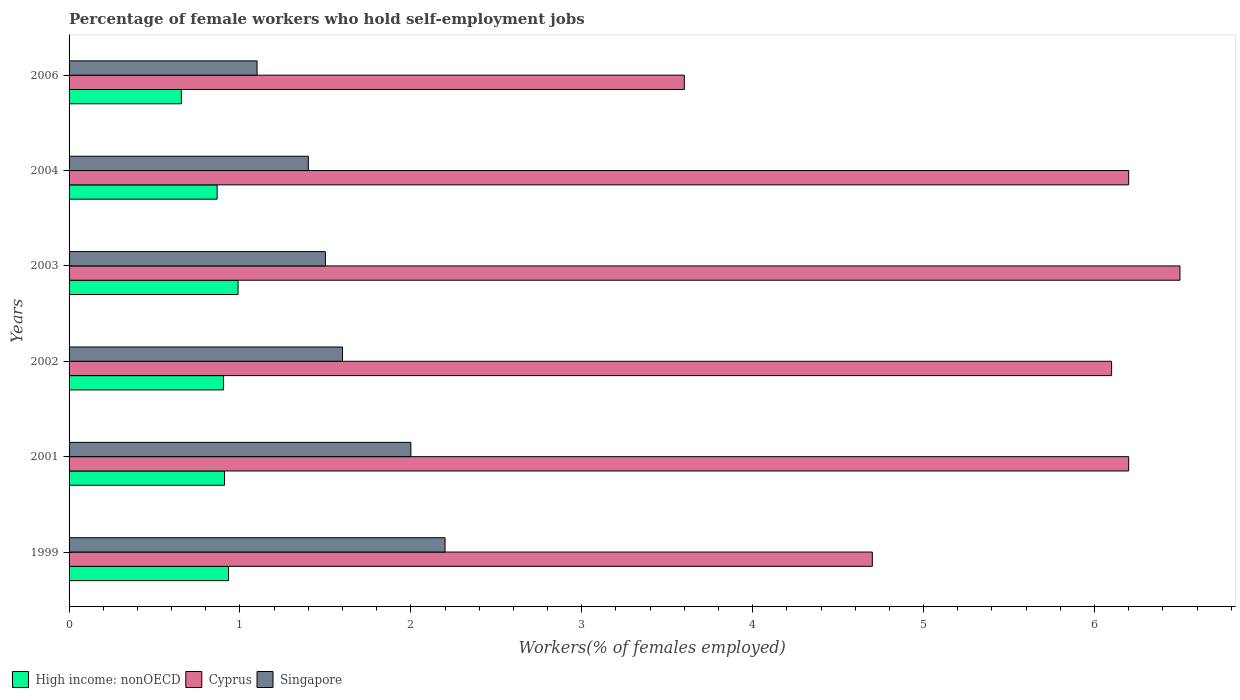How many different coloured bars are there?
Offer a terse response. 3. How many groups of bars are there?
Your answer should be very brief. 6. Are the number of bars on each tick of the Y-axis equal?
Ensure brevity in your answer.  Yes. How many bars are there on the 3rd tick from the bottom?
Your response must be concise. 3. What is the label of the 1st group of bars from the top?
Give a very brief answer. 2006. What is the percentage of self-employed female workers in Singapore in 1999?
Keep it short and to the point. 2.2. Across all years, what is the minimum percentage of self-employed female workers in Singapore?
Keep it short and to the point. 1.1. What is the total percentage of self-employed female workers in High income: nonOECD in the graph?
Your response must be concise. 5.26. What is the difference between the percentage of self-employed female workers in High income: nonOECD in 2001 and that in 2003?
Provide a short and direct response. -0.08. What is the difference between the percentage of self-employed female workers in Cyprus in 1999 and the percentage of self-employed female workers in High income: nonOECD in 2002?
Your answer should be compact. 3.8. What is the average percentage of self-employed female workers in High income: nonOECD per year?
Provide a succinct answer. 0.88. In the year 2001, what is the difference between the percentage of self-employed female workers in Singapore and percentage of self-employed female workers in Cyprus?
Your response must be concise. -4.2. What is the ratio of the percentage of self-employed female workers in High income: nonOECD in 2004 to that in 2006?
Your response must be concise. 1.32. Is the difference between the percentage of self-employed female workers in Singapore in 2001 and 2002 greater than the difference between the percentage of self-employed female workers in Cyprus in 2001 and 2002?
Provide a short and direct response. Yes. What is the difference between the highest and the second highest percentage of self-employed female workers in Cyprus?
Your answer should be very brief. 0.3. What is the difference between the highest and the lowest percentage of self-employed female workers in Singapore?
Your answer should be very brief. 1.1. In how many years, is the percentage of self-employed female workers in Singapore greater than the average percentage of self-employed female workers in Singapore taken over all years?
Provide a succinct answer. 2. Is the sum of the percentage of self-employed female workers in Singapore in 1999 and 2001 greater than the maximum percentage of self-employed female workers in High income: nonOECD across all years?
Your answer should be compact. Yes. What does the 1st bar from the top in 2002 represents?
Ensure brevity in your answer.  Singapore. What does the 2nd bar from the bottom in 2006 represents?
Your answer should be very brief. Cyprus. How many bars are there?
Give a very brief answer. 18. Are all the bars in the graph horizontal?
Provide a succinct answer. Yes. Are the values on the major ticks of X-axis written in scientific E-notation?
Provide a succinct answer. No. Does the graph contain any zero values?
Make the answer very short. No. Where does the legend appear in the graph?
Keep it short and to the point. Bottom left. How are the legend labels stacked?
Provide a succinct answer. Horizontal. What is the title of the graph?
Provide a succinct answer. Percentage of female workers who hold self-employment jobs. Does "Uzbekistan" appear as one of the legend labels in the graph?
Provide a succinct answer. No. What is the label or title of the X-axis?
Your answer should be very brief. Workers(% of females employed). What is the Workers(% of females employed) of High income: nonOECD in 1999?
Your answer should be compact. 0.93. What is the Workers(% of females employed) of Cyprus in 1999?
Your answer should be compact. 4.7. What is the Workers(% of females employed) of Singapore in 1999?
Provide a short and direct response. 2.2. What is the Workers(% of females employed) of High income: nonOECD in 2001?
Make the answer very short. 0.91. What is the Workers(% of females employed) in Cyprus in 2001?
Offer a very short reply. 6.2. What is the Workers(% of females employed) in High income: nonOECD in 2002?
Your answer should be very brief. 0.9. What is the Workers(% of females employed) in Cyprus in 2002?
Offer a very short reply. 6.1. What is the Workers(% of females employed) in Singapore in 2002?
Provide a short and direct response. 1.6. What is the Workers(% of females employed) in High income: nonOECD in 2003?
Your answer should be very brief. 0.99. What is the Workers(% of females employed) of Cyprus in 2003?
Offer a terse response. 6.5. What is the Workers(% of females employed) of High income: nonOECD in 2004?
Your answer should be very brief. 0.87. What is the Workers(% of females employed) in Cyprus in 2004?
Make the answer very short. 6.2. What is the Workers(% of females employed) of Singapore in 2004?
Offer a very short reply. 1.4. What is the Workers(% of females employed) of High income: nonOECD in 2006?
Offer a terse response. 0.66. What is the Workers(% of females employed) in Cyprus in 2006?
Ensure brevity in your answer.  3.6. What is the Workers(% of females employed) of Singapore in 2006?
Provide a short and direct response. 1.1. Across all years, what is the maximum Workers(% of females employed) in High income: nonOECD?
Offer a terse response. 0.99. Across all years, what is the maximum Workers(% of females employed) in Cyprus?
Provide a short and direct response. 6.5. Across all years, what is the maximum Workers(% of females employed) of Singapore?
Keep it short and to the point. 2.2. Across all years, what is the minimum Workers(% of females employed) in High income: nonOECD?
Your answer should be very brief. 0.66. Across all years, what is the minimum Workers(% of females employed) in Cyprus?
Your answer should be compact. 3.6. Across all years, what is the minimum Workers(% of females employed) of Singapore?
Offer a terse response. 1.1. What is the total Workers(% of females employed) of High income: nonOECD in the graph?
Your answer should be compact. 5.26. What is the total Workers(% of females employed) in Cyprus in the graph?
Ensure brevity in your answer.  33.3. What is the difference between the Workers(% of females employed) in High income: nonOECD in 1999 and that in 2001?
Give a very brief answer. 0.02. What is the difference between the Workers(% of females employed) of Cyprus in 1999 and that in 2001?
Your response must be concise. -1.5. What is the difference between the Workers(% of females employed) of High income: nonOECD in 1999 and that in 2002?
Provide a short and direct response. 0.03. What is the difference between the Workers(% of females employed) in Cyprus in 1999 and that in 2002?
Keep it short and to the point. -1.4. What is the difference between the Workers(% of females employed) of High income: nonOECD in 1999 and that in 2003?
Offer a very short reply. -0.06. What is the difference between the Workers(% of females employed) in Singapore in 1999 and that in 2003?
Make the answer very short. 0.7. What is the difference between the Workers(% of females employed) of High income: nonOECD in 1999 and that in 2004?
Provide a short and direct response. 0.07. What is the difference between the Workers(% of females employed) in High income: nonOECD in 1999 and that in 2006?
Your answer should be very brief. 0.28. What is the difference between the Workers(% of females employed) in Cyprus in 1999 and that in 2006?
Your answer should be very brief. 1.1. What is the difference between the Workers(% of females employed) in High income: nonOECD in 2001 and that in 2002?
Give a very brief answer. 0.01. What is the difference between the Workers(% of females employed) of Cyprus in 2001 and that in 2002?
Offer a very short reply. 0.1. What is the difference between the Workers(% of females employed) of Singapore in 2001 and that in 2002?
Provide a short and direct response. 0.4. What is the difference between the Workers(% of females employed) in High income: nonOECD in 2001 and that in 2003?
Your response must be concise. -0.08. What is the difference between the Workers(% of females employed) of Singapore in 2001 and that in 2003?
Provide a short and direct response. 0.5. What is the difference between the Workers(% of females employed) of High income: nonOECD in 2001 and that in 2004?
Provide a short and direct response. 0.04. What is the difference between the Workers(% of females employed) in Cyprus in 2001 and that in 2004?
Offer a terse response. 0. What is the difference between the Workers(% of females employed) in High income: nonOECD in 2001 and that in 2006?
Your answer should be very brief. 0.25. What is the difference between the Workers(% of females employed) of Cyprus in 2001 and that in 2006?
Provide a short and direct response. 2.6. What is the difference between the Workers(% of females employed) of Singapore in 2001 and that in 2006?
Keep it short and to the point. 0.9. What is the difference between the Workers(% of females employed) in High income: nonOECD in 2002 and that in 2003?
Your answer should be compact. -0.08. What is the difference between the Workers(% of females employed) of Singapore in 2002 and that in 2003?
Give a very brief answer. 0.1. What is the difference between the Workers(% of females employed) of High income: nonOECD in 2002 and that in 2004?
Your answer should be compact. 0.04. What is the difference between the Workers(% of females employed) of High income: nonOECD in 2002 and that in 2006?
Your answer should be very brief. 0.25. What is the difference between the Workers(% of females employed) in Cyprus in 2002 and that in 2006?
Provide a succinct answer. 2.5. What is the difference between the Workers(% of females employed) in Singapore in 2002 and that in 2006?
Ensure brevity in your answer.  0.5. What is the difference between the Workers(% of females employed) of High income: nonOECD in 2003 and that in 2004?
Ensure brevity in your answer.  0.12. What is the difference between the Workers(% of females employed) of High income: nonOECD in 2003 and that in 2006?
Make the answer very short. 0.33. What is the difference between the Workers(% of females employed) of Cyprus in 2003 and that in 2006?
Your answer should be very brief. 2.9. What is the difference between the Workers(% of females employed) of Singapore in 2003 and that in 2006?
Offer a very short reply. 0.4. What is the difference between the Workers(% of females employed) in High income: nonOECD in 2004 and that in 2006?
Your response must be concise. 0.21. What is the difference between the Workers(% of females employed) in Singapore in 2004 and that in 2006?
Ensure brevity in your answer.  0.3. What is the difference between the Workers(% of females employed) in High income: nonOECD in 1999 and the Workers(% of females employed) in Cyprus in 2001?
Provide a succinct answer. -5.27. What is the difference between the Workers(% of females employed) of High income: nonOECD in 1999 and the Workers(% of females employed) of Singapore in 2001?
Offer a very short reply. -1.07. What is the difference between the Workers(% of females employed) of Cyprus in 1999 and the Workers(% of females employed) of Singapore in 2001?
Keep it short and to the point. 2.7. What is the difference between the Workers(% of females employed) of High income: nonOECD in 1999 and the Workers(% of females employed) of Cyprus in 2002?
Keep it short and to the point. -5.17. What is the difference between the Workers(% of females employed) of High income: nonOECD in 1999 and the Workers(% of females employed) of Singapore in 2002?
Your answer should be very brief. -0.67. What is the difference between the Workers(% of females employed) of High income: nonOECD in 1999 and the Workers(% of females employed) of Cyprus in 2003?
Your response must be concise. -5.57. What is the difference between the Workers(% of females employed) in High income: nonOECD in 1999 and the Workers(% of females employed) in Singapore in 2003?
Your answer should be very brief. -0.57. What is the difference between the Workers(% of females employed) in Cyprus in 1999 and the Workers(% of females employed) in Singapore in 2003?
Your answer should be very brief. 3.2. What is the difference between the Workers(% of females employed) in High income: nonOECD in 1999 and the Workers(% of females employed) in Cyprus in 2004?
Ensure brevity in your answer.  -5.27. What is the difference between the Workers(% of females employed) in High income: nonOECD in 1999 and the Workers(% of females employed) in Singapore in 2004?
Make the answer very short. -0.47. What is the difference between the Workers(% of females employed) in High income: nonOECD in 1999 and the Workers(% of females employed) in Cyprus in 2006?
Offer a terse response. -2.67. What is the difference between the Workers(% of females employed) in High income: nonOECD in 1999 and the Workers(% of females employed) in Singapore in 2006?
Provide a short and direct response. -0.17. What is the difference between the Workers(% of females employed) of High income: nonOECD in 2001 and the Workers(% of females employed) of Cyprus in 2002?
Provide a succinct answer. -5.19. What is the difference between the Workers(% of females employed) of High income: nonOECD in 2001 and the Workers(% of females employed) of Singapore in 2002?
Provide a short and direct response. -0.69. What is the difference between the Workers(% of females employed) of Cyprus in 2001 and the Workers(% of females employed) of Singapore in 2002?
Keep it short and to the point. 4.6. What is the difference between the Workers(% of females employed) of High income: nonOECD in 2001 and the Workers(% of females employed) of Cyprus in 2003?
Your answer should be compact. -5.59. What is the difference between the Workers(% of females employed) in High income: nonOECD in 2001 and the Workers(% of females employed) in Singapore in 2003?
Provide a short and direct response. -0.59. What is the difference between the Workers(% of females employed) in High income: nonOECD in 2001 and the Workers(% of females employed) in Cyprus in 2004?
Make the answer very short. -5.29. What is the difference between the Workers(% of females employed) in High income: nonOECD in 2001 and the Workers(% of females employed) in Singapore in 2004?
Offer a terse response. -0.49. What is the difference between the Workers(% of females employed) in High income: nonOECD in 2001 and the Workers(% of females employed) in Cyprus in 2006?
Provide a succinct answer. -2.69. What is the difference between the Workers(% of females employed) of High income: nonOECD in 2001 and the Workers(% of females employed) of Singapore in 2006?
Ensure brevity in your answer.  -0.19. What is the difference between the Workers(% of females employed) in High income: nonOECD in 2002 and the Workers(% of females employed) in Cyprus in 2003?
Ensure brevity in your answer.  -5.6. What is the difference between the Workers(% of females employed) in High income: nonOECD in 2002 and the Workers(% of females employed) in Singapore in 2003?
Offer a very short reply. -0.6. What is the difference between the Workers(% of females employed) in High income: nonOECD in 2002 and the Workers(% of females employed) in Cyprus in 2004?
Your answer should be compact. -5.3. What is the difference between the Workers(% of females employed) of High income: nonOECD in 2002 and the Workers(% of females employed) of Singapore in 2004?
Keep it short and to the point. -0.5. What is the difference between the Workers(% of females employed) of Cyprus in 2002 and the Workers(% of females employed) of Singapore in 2004?
Provide a short and direct response. 4.7. What is the difference between the Workers(% of females employed) in High income: nonOECD in 2002 and the Workers(% of females employed) in Cyprus in 2006?
Offer a very short reply. -2.7. What is the difference between the Workers(% of females employed) in High income: nonOECD in 2002 and the Workers(% of females employed) in Singapore in 2006?
Your answer should be compact. -0.2. What is the difference between the Workers(% of females employed) of Cyprus in 2002 and the Workers(% of females employed) of Singapore in 2006?
Give a very brief answer. 5. What is the difference between the Workers(% of females employed) in High income: nonOECD in 2003 and the Workers(% of females employed) in Cyprus in 2004?
Ensure brevity in your answer.  -5.21. What is the difference between the Workers(% of females employed) in High income: nonOECD in 2003 and the Workers(% of females employed) in Singapore in 2004?
Your answer should be very brief. -0.41. What is the difference between the Workers(% of females employed) in High income: nonOECD in 2003 and the Workers(% of females employed) in Cyprus in 2006?
Make the answer very short. -2.61. What is the difference between the Workers(% of females employed) of High income: nonOECD in 2003 and the Workers(% of females employed) of Singapore in 2006?
Make the answer very short. -0.11. What is the difference between the Workers(% of females employed) of High income: nonOECD in 2004 and the Workers(% of females employed) of Cyprus in 2006?
Keep it short and to the point. -2.73. What is the difference between the Workers(% of females employed) of High income: nonOECD in 2004 and the Workers(% of females employed) of Singapore in 2006?
Keep it short and to the point. -0.23. What is the difference between the Workers(% of females employed) of Cyprus in 2004 and the Workers(% of females employed) of Singapore in 2006?
Your response must be concise. 5.1. What is the average Workers(% of females employed) of High income: nonOECD per year?
Give a very brief answer. 0.88. What is the average Workers(% of females employed) of Cyprus per year?
Ensure brevity in your answer.  5.55. What is the average Workers(% of females employed) in Singapore per year?
Offer a very short reply. 1.63. In the year 1999, what is the difference between the Workers(% of females employed) of High income: nonOECD and Workers(% of females employed) of Cyprus?
Give a very brief answer. -3.77. In the year 1999, what is the difference between the Workers(% of females employed) in High income: nonOECD and Workers(% of females employed) in Singapore?
Your answer should be compact. -1.27. In the year 2001, what is the difference between the Workers(% of females employed) of High income: nonOECD and Workers(% of females employed) of Cyprus?
Make the answer very short. -5.29. In the year 2001, what is the difference between the Workers(% of females employed) of High income: nonOECD and Workers(% of females employed) of Singapore?
Keep it short and to the point. -1.09. In the year 2001, what is the difference between the Workers(% of females employed) in Cyprus and Workers(% of females employed) in Singapore?
Offer a very short reply. 4.2. In the year 2002, what is the difference between the Workers(% of females employed) of High income: nonOECD and Workers(% of females employed) of Cyprus?
Give a very brief answer. -5.2. In the year 2002, what is the difference between the Workers(% of females employed) in High income: nonOECD and Workers(% of females employed) in Singapore?
Your answer should be compact. -0.7. In the year 2002, what is the difference between the Workers(% of females employed) in Cyprus and Workers(% of females employed) in Singapore?
Offer a terse response. 4.5. In the year 2003, what is the difference between the Workers(% of females employed) of High income: nonOECD and Workers(% of females employed) of Cyprus?
Provide a succinct answer. -5.51. In the year 2003, what is the difference between the Workers(% of females employed) of High income: nonOECD and Workers(% of females employed) of Singapore?
Provide a succinct answer. -0.51. In the year 2004, what is the difference between the Workers(% of females employed) in High income: nonOECD and Workers(% of females employed) in Cyprus?
Provide a succinct answer. -5.33. In the year 2004, what is the difference between the Workers(% of females employed) in High income: nonOECD and Workers(% of females employed) in Singapore?
Offer a terse response. -0.53. In the year 2006, what is the difference between the Workers(% of females employed) of High income: nonOECD and Workers(% of females employed) of Cyprus?
Give a very brief answer. -2.94. In the year 2006, what is the difference between the Workers(% of females employed) of High income: nonOECD and Workers(% of females employed) of Singapore?
Provide a succinct answer. -0.44. What is the ratio of the Workers(% of females employed) of High income: nonOECD in 1999 to that in 2001?
Provide a short and direct response. 1.03. What is the ratio of the Workers(% of females employed) in Cyprus in 1999 to that in 2001?
Give a very brief answer. 0.76. What is the ratio of the Workers(% of females employed) in Singapore in 1999 to that in 2001?
Make the answer very short. 1.1. What is the ratio of the Workers(% of females employed) of High income: nonOECD in 1999 to that in 2002?
Make the answer very short. 1.03. What is the ratio of the Workers(% of females employed) of Cyprus in 1999 to that in 2002?
Make the answer very short. 0.77. What is the ratio of the Workers(% of females employed) of Singapore in 1999 to that in 2002?
Ensure brevity in your answer.  1.38. What is the ratio of the Workers(% of females employed) of High income: nonOECD in 1999 to that in 2003?
Offer a terse response. 0.94. What is the ratio of the Workers(% of females employed) of Cyprus in 1999 to that in 2003?
Ensure brevity in your answer.  0.72. What is the ratio of the Workers(% of females employed) in Singapore in 1999 to that in 2003?
Provide a succinct answer. 1.47. What is the ratio of the Workers(% of females employed) in High income: nonOECD in 1999 to that in 2004?
Offer a terse response. 1.08. What is the ratio of the Workers(% of females employed) in Cyprus in 1999 to that in 2004?
Your response must be concise. 0.76. What is the ratio of the Workers(% of females employed) in Singapore in 1999 to that in 2004?
Offer a terse response. 1.57. What is the ratio of the Workers(% of females employed) in High income: nonOECD in 1999 to that in 2006?
Give a very brief answer. 1.42. What is the ratio of the Workers(% of females employed) of Cyprus in 1999 to that in 2006?
Give a very brief answer. 1.31. What is the ratio of the Workers(% of females employed) in Singapore in 1999 to that in 2006?
Your response must be concise. 2. What is the ratio of the Workers(% of females employed) in High income: nonOECD in 2001 to that in 2002?
Provide a short and direct response. 1.01. What is the ratio of the Workers(% of females employed) in Cyprus in 2001 to that in 2002?
Keep it short and to the point. 1.02. What is the ratio of the Workers(% of females employed) in Singapore in 2001 to that in 2002?
Make the answer very short. 1.25. What is the ratio of the Workers(% of females employed) in High income: nonOECD in 2001 to that in 2003?
Your response must be concise. 0.92. What is the ratio of the Workers(% of females employed) in Cyprus in 2001 to that in 2003?
Make the answer very short. 0.95. What is the ratio of the Workers(% of females employed) of High income: nonOECD in 2001 to that in 2004?
Offer a very short reply. 1.05. What is the ratio of the Workers(% of females employed) of Cyprus in 2001 to that in 2004?
Provide a succinct answer. 1. What is the ratio of the Workers(% of females employed) of Singapore in 2001 to that in 2004?
Ensure brevity in your answer.  1.43. What is the ratio of the Workers(% of females employed) of High income: nonOECD in 2001 to that in 2006?
Your answer should be compact. 1.38. What is the ratio of the Workers(% of females employed) in Cyprus in 2001 to that in 2006?
Give a very brief answer. 1.72. What is the ratio of the Workers(% of females employed) in Singapore in 2001 to that in 2006?
Provide a succinct answer. 1.82. What is the ratio of the Workers(% of females employed) of High income: nonOECD in 2002 to that in 2003?
Provide a short and direct response. 0.91. What is the ratio of the Workers(% of females employed) in Cyprus in 2002 to that in 2003?
Provide a succinct answer. 0.94. What is the ratio of the Workers(% of females employed) in Singapore in 2002 to that in 2003?
Make the answer very short. 1.07. What is the ratio of the Workers(% of females employed) of High income: nonOECD in 2002 to that in 2004?
Give a very brief answer. 1.04. What is the ratio of the Workers(% of females employed) of Cyprus in 2002 to that in 2004?
Keep it short and to the point. 0.98. What is the ratio of the Workers(% of females employed) in High income: nonOECD in 2002 to that in 2006?
Your answer should be very brief. 1.38. What is the ratio of the Workers(% of females employed) of Cyprus in 2002 to that in 2006?
Offer a terse response. 1.69. What is the ratio of the Workers(% of females employed) of Singapore in 2002 to that in 2006?
Provide a short and direct response. 1.45. What is the ratio of the Workers(% of females employed) in High income: nonOECD in 2003 to that in 2004?
Offer a terse response. 1.14. What is the ratio of the Workers(% of females employed) of Cyprus in 2003 to that in 2004?
Offer a very short reply. 1.05. What is the ratio of the Workers(% of females employed) in Singapore in 2003 to that in 2004?
Your answer should be compact. 1.07. What is the ratio of the Workers(% of females employed) of High income: nonOECD in 2003 to that in 2006?
Provide a short and direct response. 1.5. What is the ratio of the Workers(% of females employed) of Cyprus in 2003 to that in 2006?
Keep it short and to the point. 1.81. What is the ratio of the Workers(% of females employed) of Singapore in 2003 to that in 2006?
Your answer should be compact. 1.36. What is the ratio of the Workers(% of females employed) in High income: nonOECD in 2004 to that in 2006?
Offer a terse response. 1.32. What is the ratio of the Workers(% of females employed) in Cyprus in 2004 to that in 2006?
Your answer should be very brief. 1.72. What is the ratio of the Workers(% of females employed) in Singapore in 2004 to that in 2006?
Offer a very short reply. 1.27. What is the difference between the highest and the second highest Workers(% of females employed) of High income: nonOECD?
Give a very brief answer. 0.06. What is the difference between the highest and the second highest Workers(% of females employed) of Singapore?
Provide a succinct answer. 0.2. What is the difference between the highest and the lowest Workers(% of females employed) of High income: nonOECD?
Make the answer very short. 0.33. What is the difference between the highest and the lowest Workers(% of females employed) in Cyprus?
Give a very brief answer. 2.9. What is the difference between the highest and the lowest Workers(% of females employed) in Singapore?
Your answer should be very brief. 1.1. 